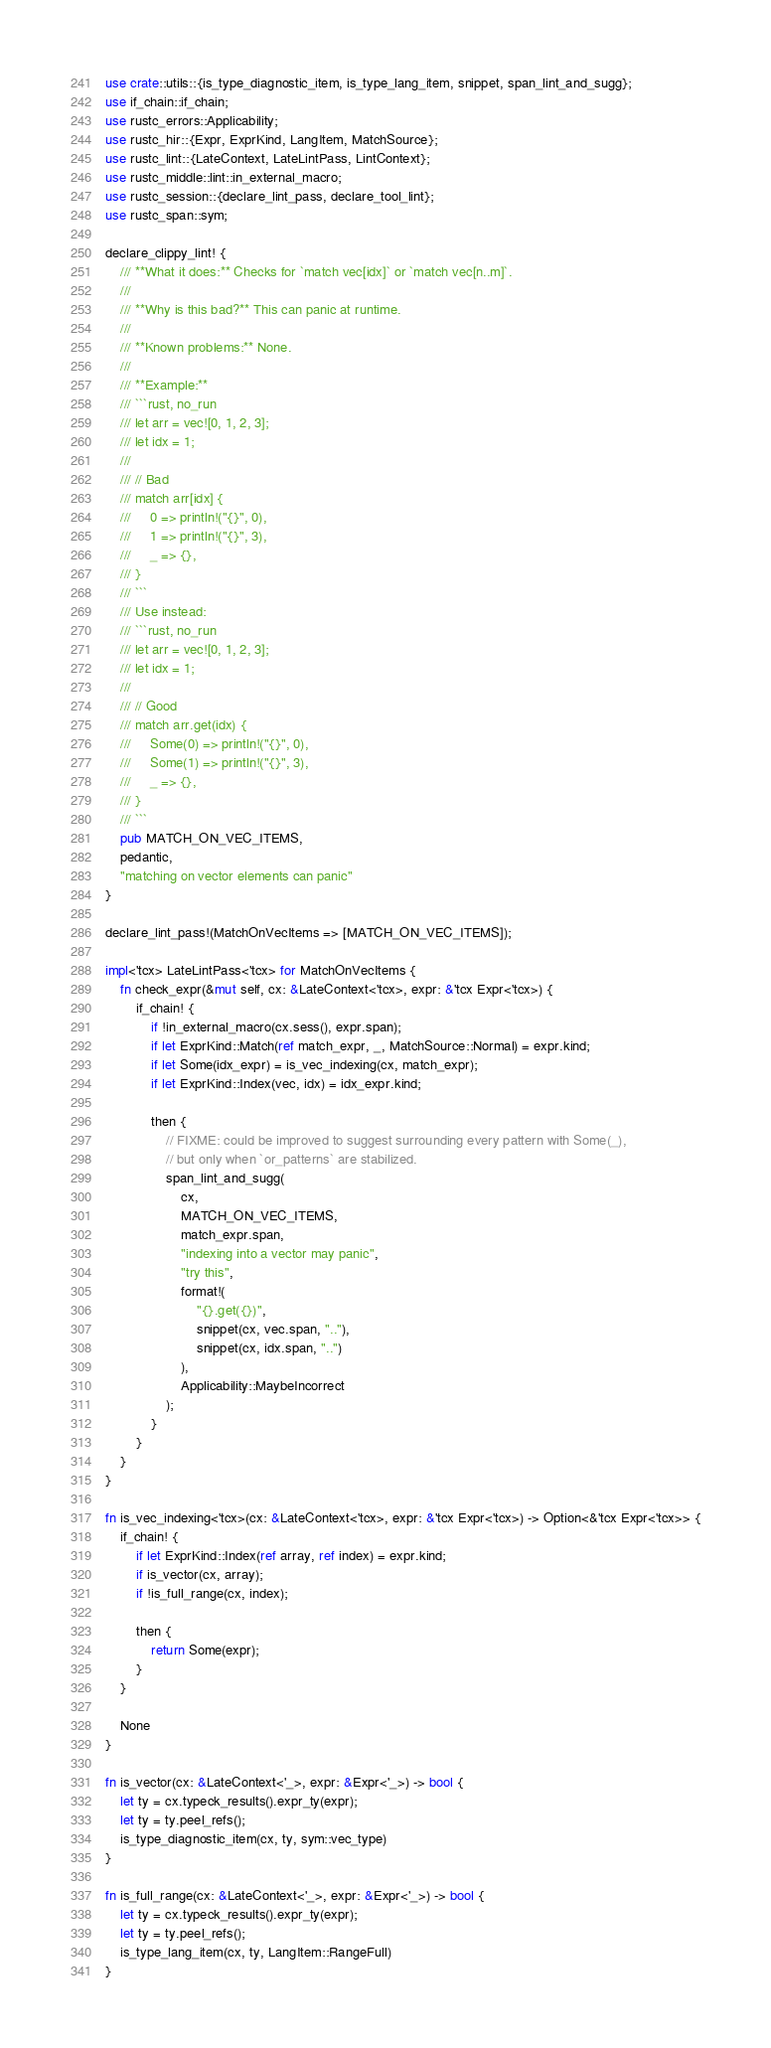<code> <loc_0><loc_0><loc_500><loc_500><_Rust_>use crate::utils::{is_type_diagnostic_item, is_type_lang_item, snippet, span_lint_and_sugg};
use if_chain::if_chain;
use rustc_errors::Applicability;
use rustc_hir::{Expr, ExprKind, LangItem, MatchSource};
use rustc_lint::{LateContext, LateLintPass, LintContext};
use rustc_middle::lint::in_external_macro;
use rustc_session::{declare_lint_pass, declare_tool_lint};
use rustc_span::sym;

declare_clippy_lint! {
    /// **What it does:** Checks for `match vec[idx]` or `match vec[n..m]`.
    ///
    /// **Why is this bad?** This can panic at runtime.
    ///
    /// **Known problems:** None.
    ///
    /// **Example:**
    /// ```rust, no_run
    /// let arr = vec![0, 1, 2, 3];
    /// let idx = 1;
    ///
    /// // Bad
    /// match arr[idx] {
    ///     0 => println!("{}", 0),
    ///     1 => println!("{}", 3),
    ///     _ => {},
    /// }
    /// ```
    /// Use instead:
    /// ```rust, no_run
    /// let arr = vec![0, 1, 2, 3];
    /// let idx = 1;
    ///
    /// // Good
    /// match arr.get(idx) {
    ///     Some(0) => println!("{}", 0),
    ///     Some(1) => println!("{}", 3),
    ///     _ => {},
    /// }
    /// ```
    pub MATCH_ON_VEC_ITEMS,
    pedantic,
    "matching on vector elements can panic"
}

declare_lint_pass!(MatchOnVecItems => [MATCH_ON_VEC_ITEMS]);

impl<'tcx> LateLintPass<'tcx> for MatchOnVecItems {
    fn check_expr(&mut self, cx: &LateContext<'tcx>, expr: &'tcx Expr<'tcx>) {
        if_chain! {
            if !in_external_macro(cx.sess(), expr.span);
            if let ExprKind::Match(ref match_expr, _, MatchSource::Normal) = expr.kind;
            if let Some(idx_expr) = is_vec_indexing(cx, match_expr);
            if let ExprKind::Index(vec, idx) = idx_expr.kind;

            then {
                // FIXME: could be improved to suggest surrounding every pattern with Some(_),
                // but only when `or_patterns` are stabilized.
                span_lint_and_sugg(
                    cx,
                    MATCH_ON_VEC_ITEMS,
                    match_expr.span,
                    "indexing into a vector may panic",
                    "try this",
                    format!(
                        "{}.get({})",
                        snippet(cx, vec.span, ".."),
                        snippet(cx, idx.span, "..")
                    ),
                    Applicability::MaybeIncorrect
                );
            }
        }
    }
}

fn is_vec_indexing<'tcx>(cx: &LateContext<'tcx>, expr: &'tcx Expr<'tcx>) -> Option<&'tcx Expr<'tcx>> {
    if_chain! {
        if let ExprKind::Index(ref array, ref index) = expr.kind;
        if is_vector(cx, array);
        if !is_full_range(cx, index);

        then {
            return Some(expr);
        }
    }

    None
}

fn is_vector(cx: &LateContext<'_>, expr: &Expr<'_>) -> bool {
    let ty = cx.typeck_results().expr_ty(expr);
    let ty = ty.peel_refs();
    is_type_diagnostic_item(cx, ty, sym::vec_type)
}

fn is_full_range(cx: &LateContext<'_>, expr: &Expr<'_>) -> bool {
    let ty = cx.typeck_results().expr_ty(expr);
    let ty = ty.peel_refs();
    is_type_lang_item(cx, ty, LangItem::RangeFull)
}
</code> 